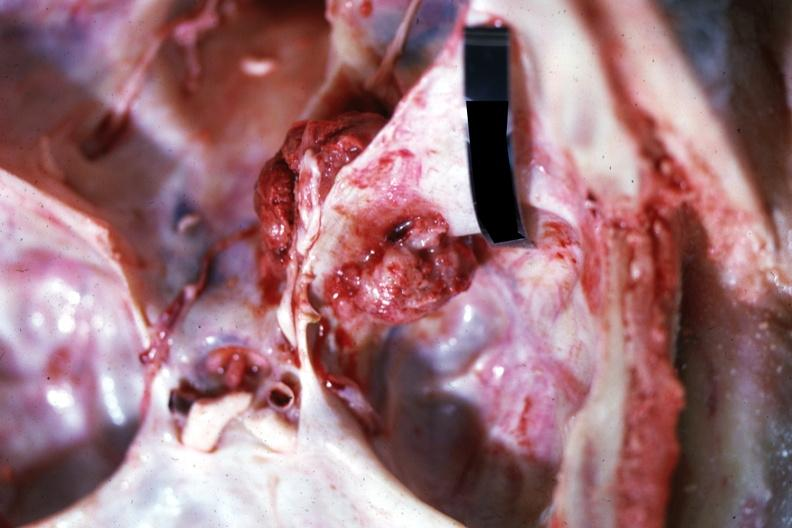what is present?
Answer the question using a single word or phrase. Bone, skull 